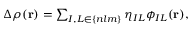Convert formula to latex. <formula><loc_0><loc_0><loc_500><loc_500>\begin{array} { r } { \Delta \rho ( { r } ) = \sum _ { I , L \in \{ n l m \} } \eta _ { I L } \phi _ { I L } ( { r } ) , } \end{array}</formula> 